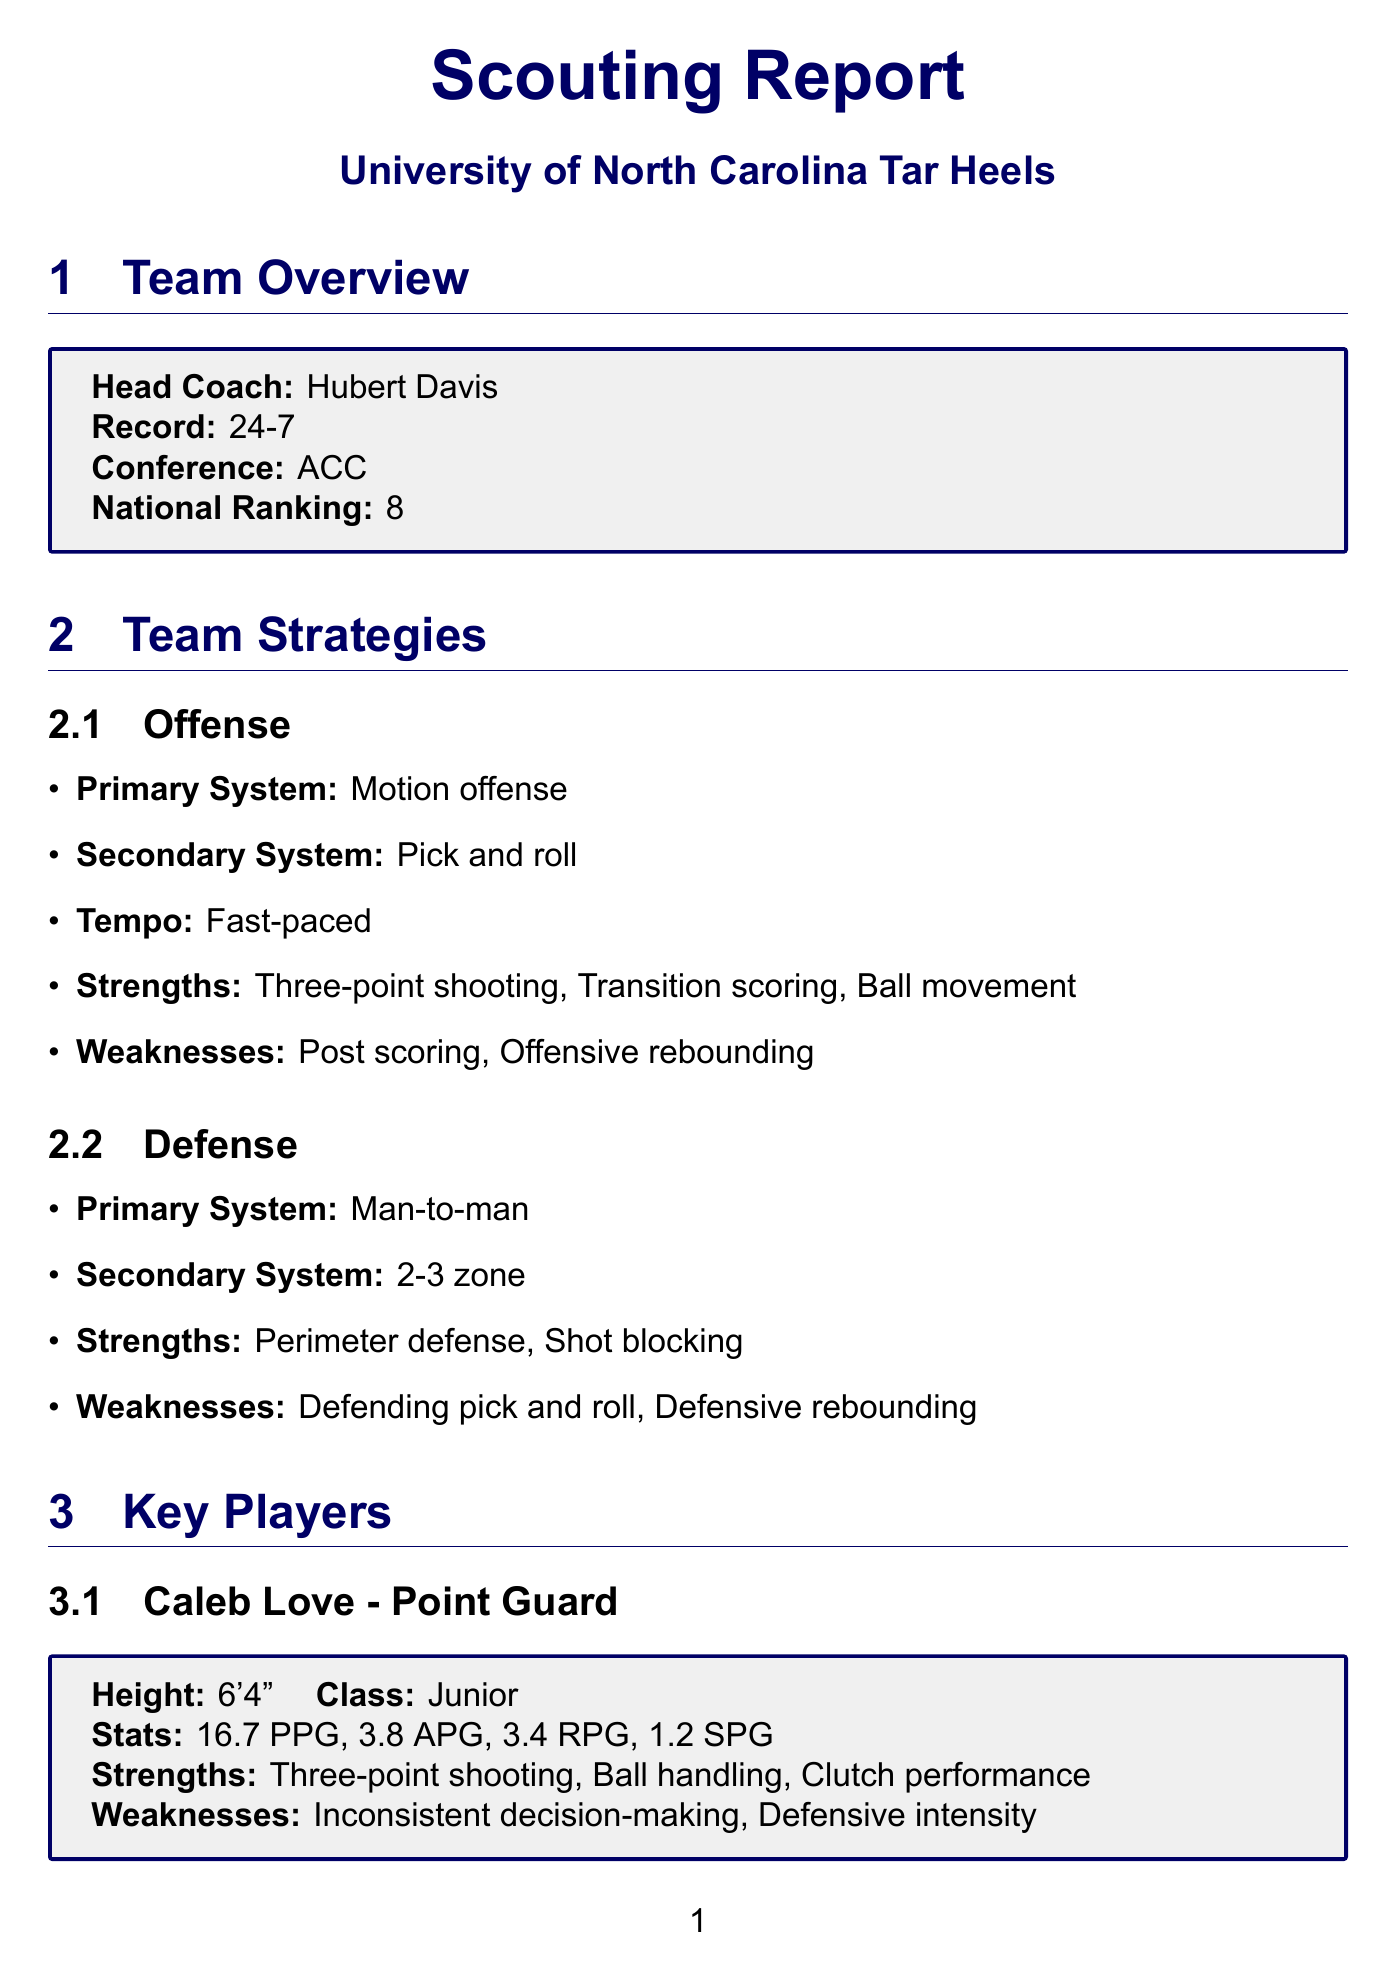What is the head coach's name? The head coach's name is provided in the team overview section of the document.
Answer: Hubert Davis What is the team's current record? The current record is found in the team overview section.
Answer: 24-7 What is the primary offensive system? The primary offensive system is listed in the team strategies section.
Answer: Motion offense What is Armando Bacot's height? Armando Bacot's height is mentioned in the key players section.
Answer: 6'10" What were the total points scored by UNC against Virginia Tech? The score against Virginia Tech is noted in the recent game analysis section.
Answer: 88 What is a key strength in UNC's offense? A key strength is listed under the team's offensive strengths in the strategies section.
Answer: Three-point shooting What injury does Puff Johnson have? Puff Johnson's injury is specified in the injury report section.
Answer: Knee soreness What is the points allowed per game? The points allowed metric is found in the statistical trends section of the document.
Answer: 70.8 What is the late game strategy for UNC? This information is provided in the coaching tendencies section under late-game strategies.
Answer: Isolation plays for Caleb Love How many rebounds does Armando Bacot average per game? Armando Bacot's rebounding average is included in his player statistics.
Answer: 10.4 